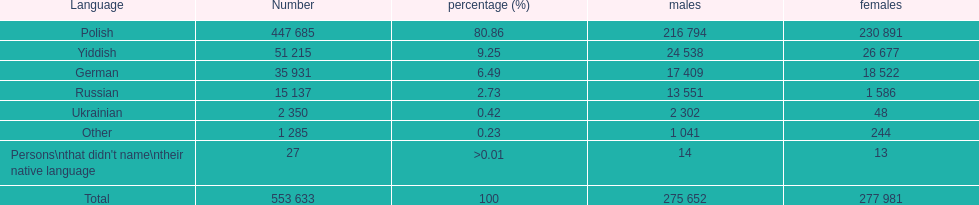What is the count of people speaking polish? 447 685. How many speakers does the yiddish language have? 51 215. What is the sum of speakers for both languages? 553 633. 